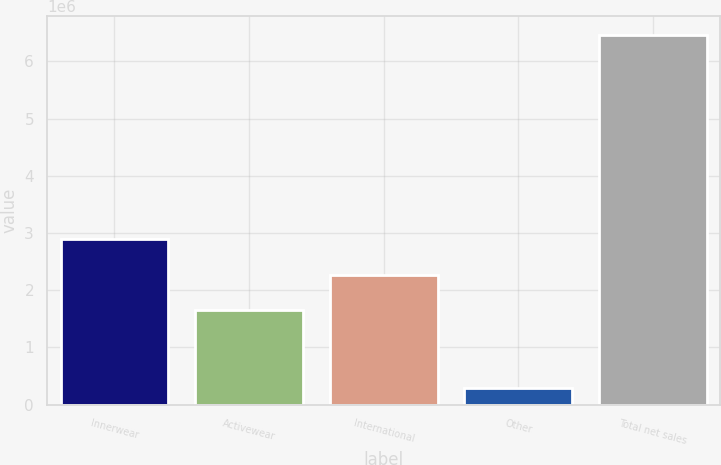Convert chart to OTSL. <chart><loc_0><loc_0><loc_500><loc_500><bar_chart><fcel>Innerwear<fcel>Activewear<fcel>International<fcel>Other<fcel>Total net sales<nl><fcel>2.88864e+06<fcel>1.65428e+06<fcel>2.27146e+06<fcel>299592<fcel>6.47141e+06<nl></chart> 